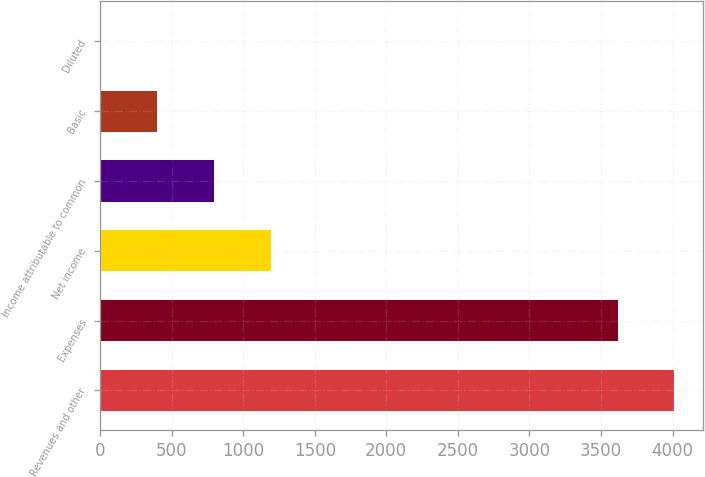<chart> <loc_0><loc_0><loc_500><loc_500><bar_chart><fcel>Revenues and other<fcel>Expenses<fcel>Net income<fcel>Income attributable to common<fcel>Basic<fcel>Diluted<nl><fcel>4013.11<fcel>3616<fcel>1192.19<fcel>795.08<fcel>397.97<fcel>0.86<nl></chart> 